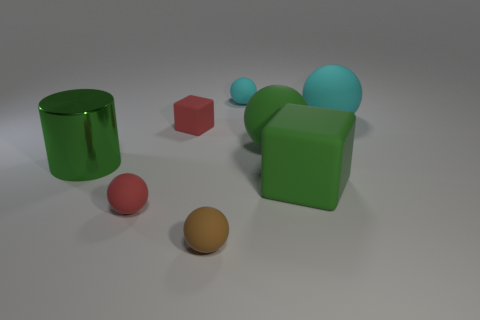Does the metal cylinder have the same color as the big block?
Provide a short and direct response. Yes. There is a big block that is the same color as the big shiny object; what is its material?
Your answer should be very brief. Rubber. Are there the same number of large green things that are on the left side of the large green shiny thing and large matte objects?
Give a very brief answer. No. Are there any large metal cylinders on the right side of the big cyan sphere?
Provide a succinct answer. No. There is a brown thing; is it the same shape as the small red thing that is behind the large green metal cylinder?
Ensure brevity in your answer.  No. What is the color of the other cube that is made of the same material as the large cube?
Offer a very short reply. Red. The big cylinder has what color?
Make the answer very short. Green. Is the material of the brown object the same as the red object that is in front of the red block?
Offer a very short reply. Yes. What number of matte objects are in front of the green cylinder and to the left of the green matte cube?
Give a very brief answer. 2. What is the shape of the brown thing that is the same size as the red rubber sphere?
Your response must be concise. Sphere. 